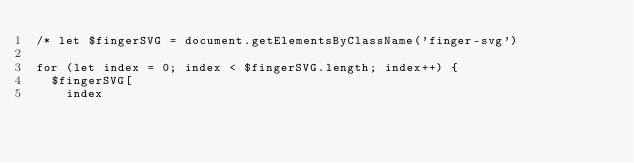<code> <loc_0><loc_0><loc_500><loc_500><_JavaScript_>/* let $fingerSVG = document.getElementsByClassName('finger-svg')

for (let index = 0; index < $fingerSVG.length; index++) {
  $fingerSVG[
    index</code> 